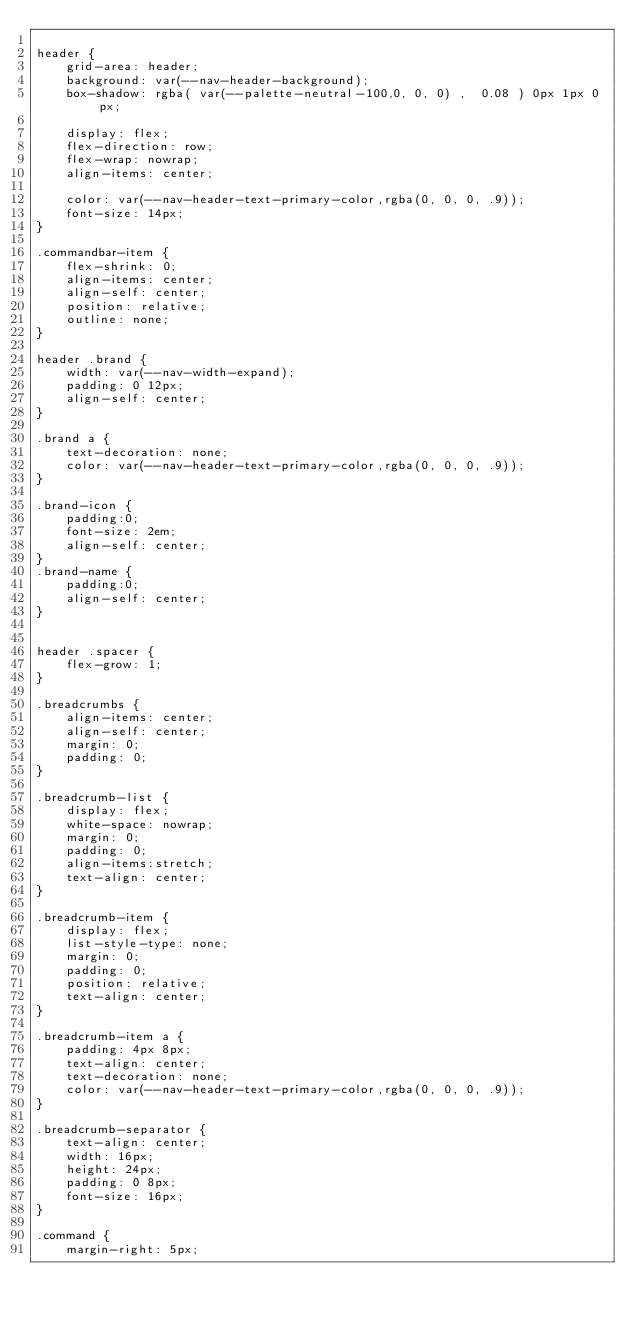Convert code to text. <code><loc_0><loc_0><loc_500><loc_500><_CSS_>
header {
    grid-area: header;
    background: var(--nav-header-background);
    box-shadow: rgba( var(--palette-neutral-100,0, 0, 0) ,  0.08 ) 0px 1px 0px;

    display: flex;
    flex-direction: row;
    flex-wrap: nowrap;
    align-items: center;

    color: var(--nav-header-text-primary-color,rgba(0, 0, 0, .9));
    font-size: 14px;
}

.commandbar-item {
    flex-shrink: 0;
    align-items: center;
    align-self: center;
    position: relative;
    outline: none;
}

header .brand {
    width: var(--nav-width-expand);
    padding: 0 12px;
    align-self: center;
}

.brand a {
    text-decoration: none;
    color: var(--nav-header-text-primary-color,rgba(0, 0, 0, .9));
}

.brand-icon {
    padding:0;
    font-size: 2em;
    align-self: center;
}
.brand-name {
    padding:0;
    align-self: center;
}


header .spacer {
    flex-grow: 1;
}

.breadcrumbs {
    align-items: center;
    align-self: center;
    margin: 0;
    padding: 0;
}

.breadcrumb-list {
    display: flex;
    white-space: nowrap;
    margin: 0;
    padding: 0;
    align-items:stretch;
    text-align: center;
}

.breadcrumb-item {
    display: flex;
    list-style-type: none;
    margin: 0;
    padding: 0;
    position: relative;
    text-align: center;
}

.breadcrumb-item a {
    padding: 4px 8px;
    text-align: center;
    text-decoration: none;
    color: var(--nav-header-text-primary-color,rgba(0, 0, 0, .9));
}

.breadcrumb-separator {
    text-align: center;
    width: 16px;
    height: 24px;
    padding: 0 8px;
    font-size: 16px;
}

.command {
    margin-right: 5px;</code> 